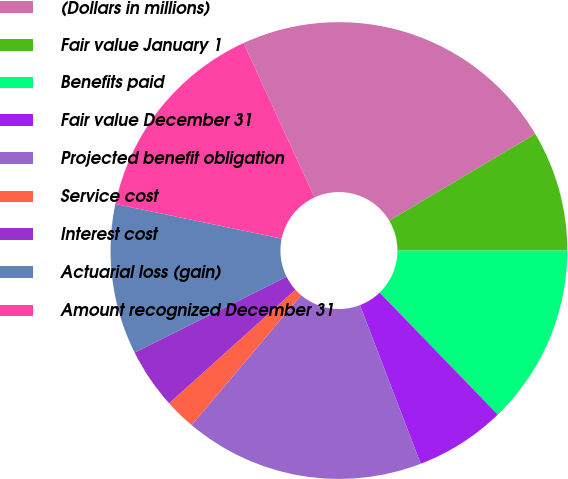Convert chart. <chart><loc_0><loc_0><loc_500><loc_500><pie_chart><fcel>(Dollars in millions)<fcel>Fair value January 1<fcel>Benefits paid<fcel>Fair value December 31<fcel>Projected benefit obligation<fcel>Service cost<fcel>Interest cost<fcel>Actuarial loss (gain)<fcel>Amount recognized December 31<nl><fcel>23.33%<fcel>8.53%<fcel>12.76%<fcel>6.41%<fcel>16.99%<fcel>2.18%<fcel>4.29%<fcel>10.64%<fcel>14.87%<nl></chart> 